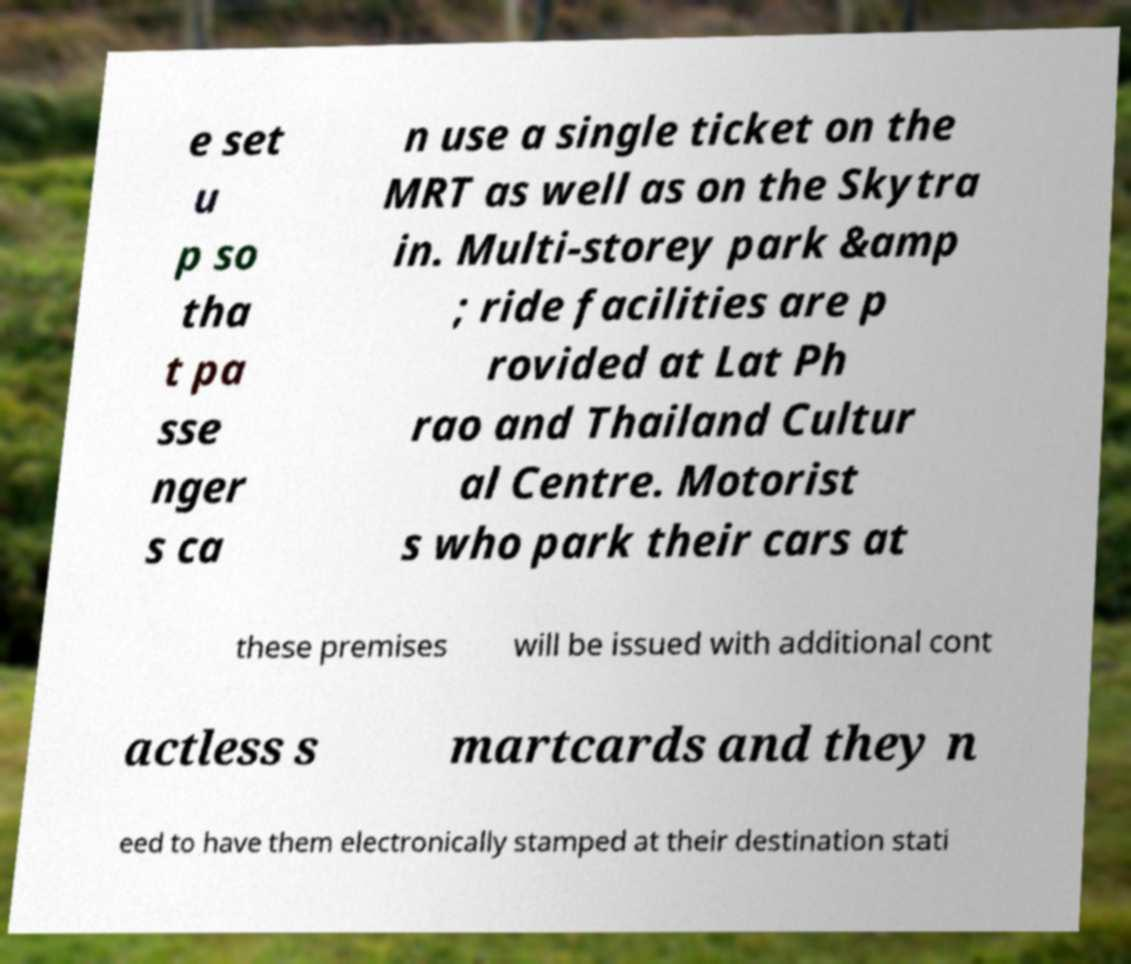Can you read and provide the text displayed in the image?This photo seems to have some interesting text. Can you extract and type it out for me? e set u p so tha t pa sse nger s ca n use a single ticket on the MRT as well as on the Skytra in. Multi-storey park &amp ; ride facilities are p rovided at Lat Ph rao and Thailand Cultur al Centre. Motorist s who park their cars at these premises will be issued with additional cont actless s martcards and they n eed to have them electronically stamped at their destination stati 